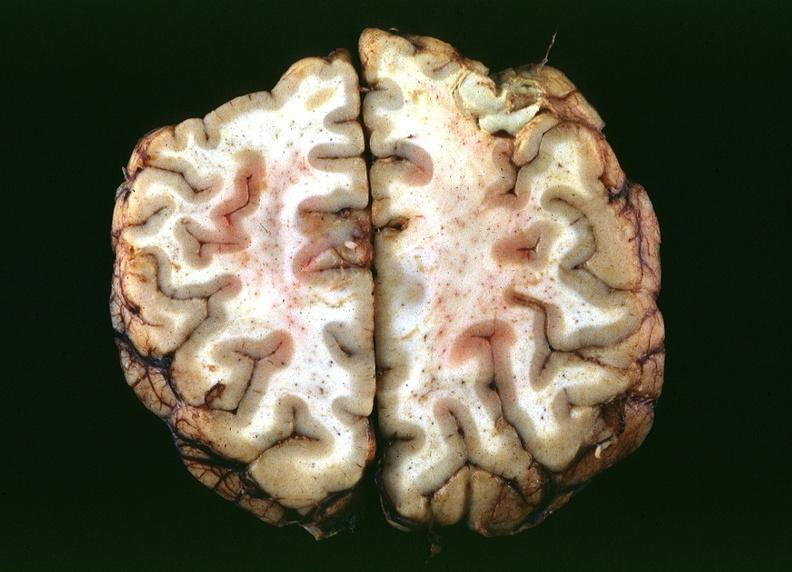does hemorrhagic corpus luteum show toxoplasmosis, brain?
Answer the question using a single word or phrase. No 